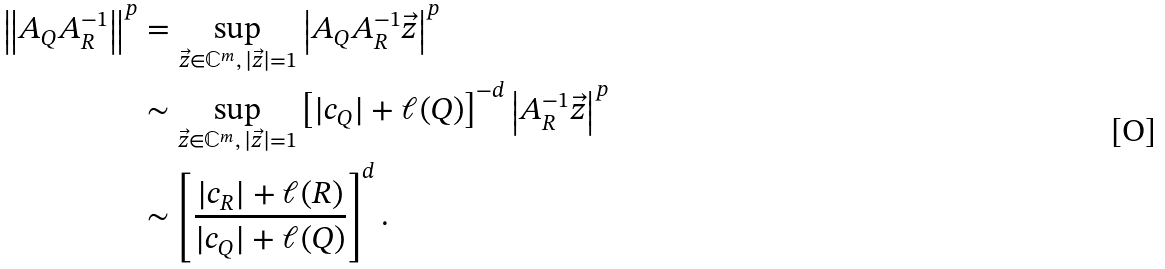<formula> <loc_0><loc_0><loc_500><loc_500>\left \| A _ { Q } A _ { R } ^ { - 1 } \right \| ^ { p } & = \sup _ { \vec { z } \in \mathbb { C } ^ { m } , \, | \vec { z } | = 1 } \left | A _ { Q } A _ { R } ^ { - 1 } \vec { z } \right | ^ { p } \\ & \sim \sup _ { \vec { z } \in \mathbb { C } ^ { m } , \, | \vec { z } | = 1 } \left [ | c _ { Q } | + \ell ( Q ) \right ] ^ { - d } \left | A _ { R } ^ { - 1 } \vec { z } \right | ^ { p } \\ & \sim \left [ \frac { | c _ { R } | + \ell ( R ) } { | c _ { Q } | + \ell ( Q ) } \right ] ^ { d } .</formula> 